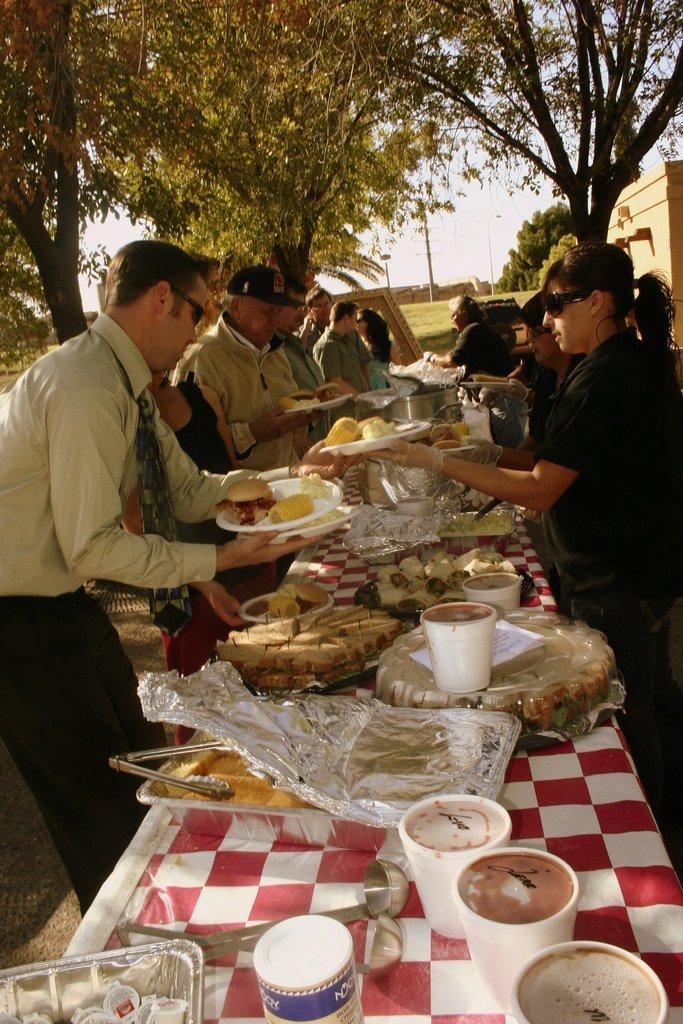Please provide a concise description of this image. There are group of people standing and holding plates. This is a table covered with a cloth. These are the bowls,tray,glasses,plates and few other things placed on the table. These are the trees. At background i can see building. 